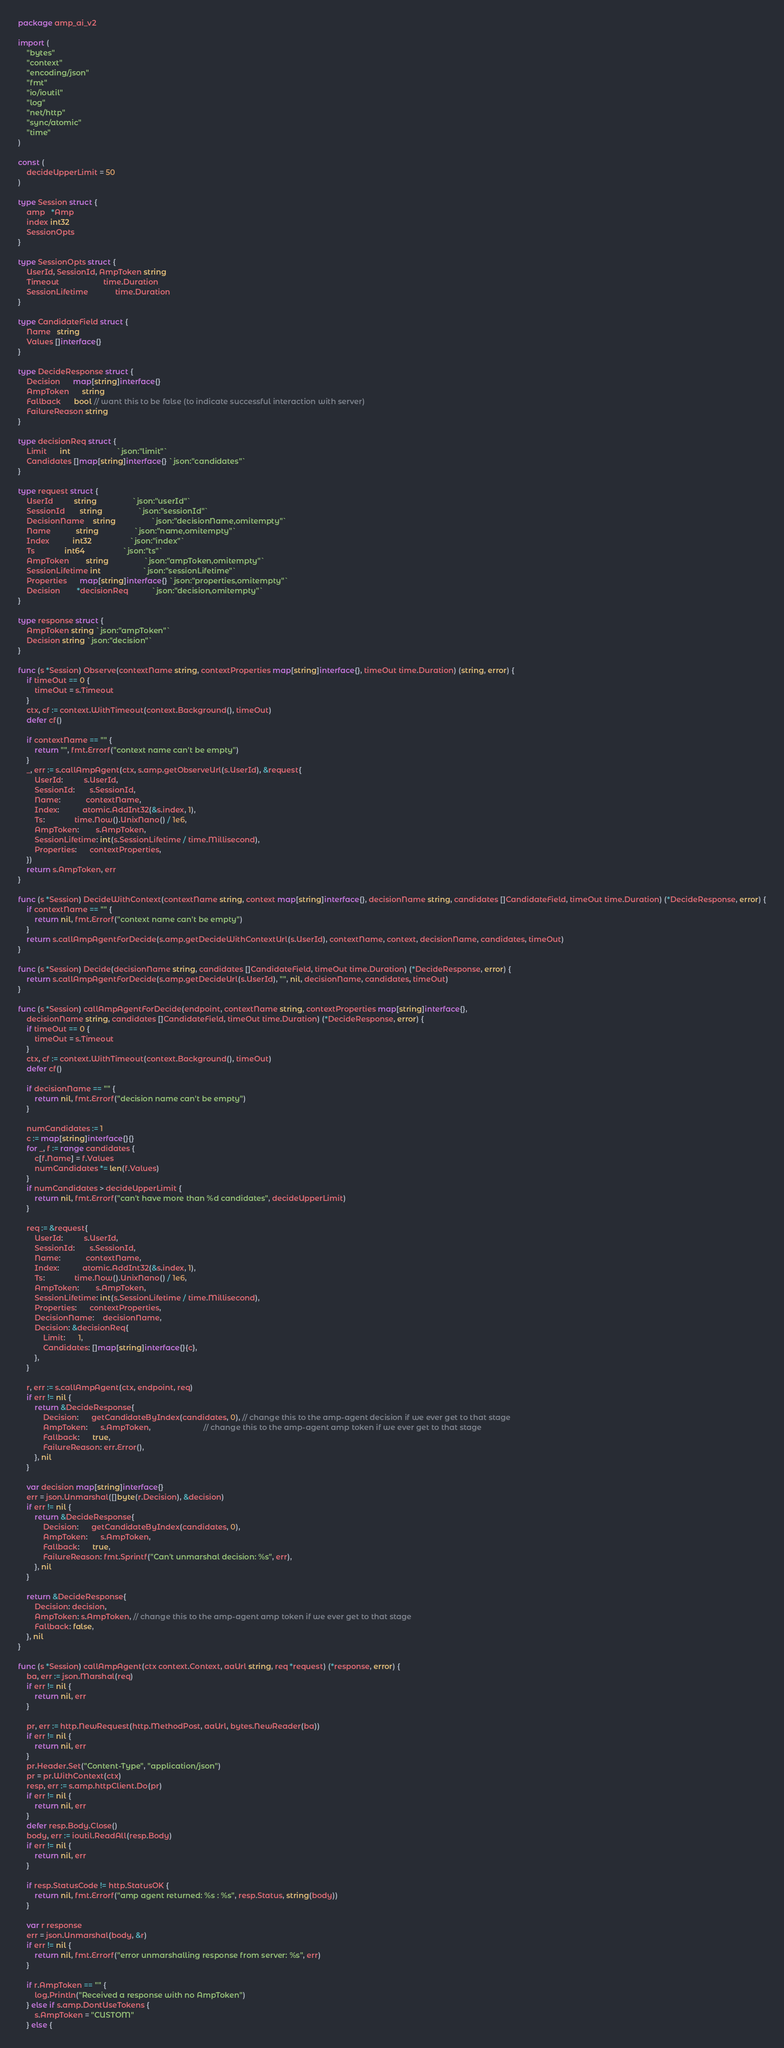<code> <loc_0><loc_0><loc_500><loc_500><_Go_>package amp_ai_v2

import (
	"bytes"
	"context"
	"encoding/json"
	"fmt"
	"io/ioutil"
	"log"
	"net/http"
	"sync/atomic"
	"time"
)

const (
	decideUpperLimit = 50
)

type Session struct {
	amp   *Amp
	index int32
	SessionOpts
}

type SessionOpts struct {
	UserId, SessionId, AmpToken string
	Timeout                     time.Duration
	SessionLifetime             time.Duration
}

type CandidateField struct {
	Name   string
	Values []interface{}
}

type DecideResponse struct {
	Decision      map[string]interface{}
	AmpToken      string
	Fallback      bool // want this to be false (to indicate successful interaction with server)
	FailureReason string
}

type decisionReq struct {
	Limit      int                      `json:"limit"`
	Candidates []map[string]interface{} `json:"candidates"`
}

type request struct {
	UserId          string                 `json:"userId"`
	SessionId       string                 `json:"sessionId"`
	DecisionName    string                 `json:"decisionName,omitempty"`
	Name            string                 `json:"name,omitempty"`
	Index           int32                  `json:"index"`
	Ts              int64                  `json:"ts"`
	AmpToken        string                 `json:"ampToken,omitempty"`
	SessionLifetime int                    `json:"sessionLifetime"`
	Properties      map[string]interface{} `json:"properties,omitempty"`
	Decision        *decisionReq           `json:"decision,omitempty"`
}

type response struct {
	AmpToken string `json:"ampToken"`
	Decision string `json:"decision"`
}

func (s *Session) Observe(contextName string, contextProperties map[string]interface{}, timeOut time.Duration) (string, error) {
	if timeOut == 0 {
		timeOut = s.Timeout
	}
	ctx, cf := context.WithTimeout(context.Background(), timeOut)
	defer cf()

	if contextName == "" {
		return "", fmt.Errorf("context name can't be empty")
	}
	_, err := s.callAmpAgent(ctx, s.amp.getObserveUrl(s.UserId), &request{
		UserId:          s.UserId,
		SessionId:       s.SessionId,
		Name:            contextName,
		Index:           atomic.AddInt32(&s.index, 1),
		Ts:              time.Now().UnixNano() / 1e6,
		AmpToken:        s.AmpToken,
		SessionLifetime: int(s.SessionLifetime / time.Millisecond),
		Properties:      contextProperties,
	})
	return s.AmpToken, err
}

func (s *Session) DecideWithContext(contextName string, context map[string]interface{}, decisionName string, candidates []CandidateField, timeOut time.Duration) (*DecideResponse, error) {
	if contextName == "" {
		return nil, fmt.Errorf("context name can't be empty")
	}
	return s.callAmpAgentForDecide(s.amp.getDecideWithContextUrl(s.UserId), contextName, context, decisionName, candidates, timeOut)
}

func (s *Session) Decide(decisionName string, candidates []CandidateField, timeOut time.Duration) (*DecideResponse, error) {
	return s.callAmpAgentForDecide(s.amp.getDecideUrl(s.UserId), "", nil, decisionName, candidates, timeOut)
}

func (s *Session) callAmpAgentForDecide(endpoint, contextName string, contextProperties map[string]interface{},
	decisionName string, candidates []CandidateField, timeOut time.Duration) (*DecideResponse, error) {
	if timeOut == 0 {
		timeOut = s.Timeout
	}
	ctx, cf := context.WithTimeout(context.Background(), timeOut)
	defer cf()

	if decisionName == "" {
		return nil, fmt.Errorf("decision name can't be empty")
	}

	numCandidates := 1
	c := map[string]interface{}{}
	for _, f := range candidates {
		c[f.Name] = f.Values
		numCandidates *= len(f.Values)
	}
	if numCandidates > decideUpperLimit {
		return nil, fmt.Errorf("can't have more than %d candidates", decideUpperLimit)
	}

	req := &request{
		UserId:          s.UserId,
		SessionId:       s.SessionId,
		Name:            contextName,
		Index:           atomic.AddInt32(&s.index, 1),
		Ts:              time.Now().UnixNano() / 1e6,
		AmpToken:        s.AmpToken,
		SessionLifetime: int(s.SessionLifetime / time.Millisecond),
		Properties:      contextProperties,
		DecisionName:    decisionName,
		Decision: &decisionReq{
			Limit:      1,
			Candidates: []map[string]interface{}{c},
		},
	}

	r, err := s.callAmpAgent(ctx, endpoint, req)
	if err != nil {
		return &DecideResponse{
			Decision:      getCandidateByIndex(candidates, 0), // change this to the amp-agent decision if we ever get to that stage
			AmpToken:      s.AmpToken,                         // change this to the amp-agent amp token if we ever get to that stage
			Fallback:      true,
			FailureReason: err.Error(),
		}, nil
	}

	var decision map[string]interface{}
	err = json.Unmarshal([]byte(r.Decision), &decision)
	if err != nil {
		return &DecideResponse{
			Decision:      getCandidateByIndex(candidates, 0),
			AmpToken:      s.AmpToken,
			Fallback:      true,
			FailureReason: fmt.Sprintf("Can't unmarshal decision: %s", err),
		}, nil
	}

	return &DecideResponse{
		Decision: decision,
		AmpToken: s.AmpToken, // change this to the amp-agent amp token if we ever get to that stage
		Fallback: false,
	}, nil
}

func (s *Session) callAmpAgent(ctx context.Context, aaUrl string, req *request) (*response, error) {
	ba, err := json.Marshal(req)
	if err != nil {
		return nil, err
	}

	pr, err := http.NewRequest(http.MethodPost, aaUrl, bytes.NewReader(ba))
	if err != nil {
		return nil, err
	}
	pr.Header.Set("Content-Type", "application/json")
	pr = pr.WithContext(ctx)
	resp, err := s.amp.httpClient.Do(pr)
	if err != nil {
		return nil, err
	}
	defer resp.Body.Close()
	body, err := ioutil.ReadAll(resp.Body)
	if err != nil {
		return nil, err
	}

	if resp.StatusCode != http.StatusOK {
		return nil, fmt.Errorf("amp agent returned: %s : %s", resp.Status, string(body))
	}

	var r response
	err = json.Unmarshal(body, &r)
	if err != nil {
		return nil, fmt.Errorf("error unmarshalling response from server: %s", err)
	}

	if r.AmpToken == "" {
		log.Println("Received a response with no AmpToken")
	} else if s.amp.DontUseTokens {
		s.AmpToken = "CUSTOM"
	} else {</code> 